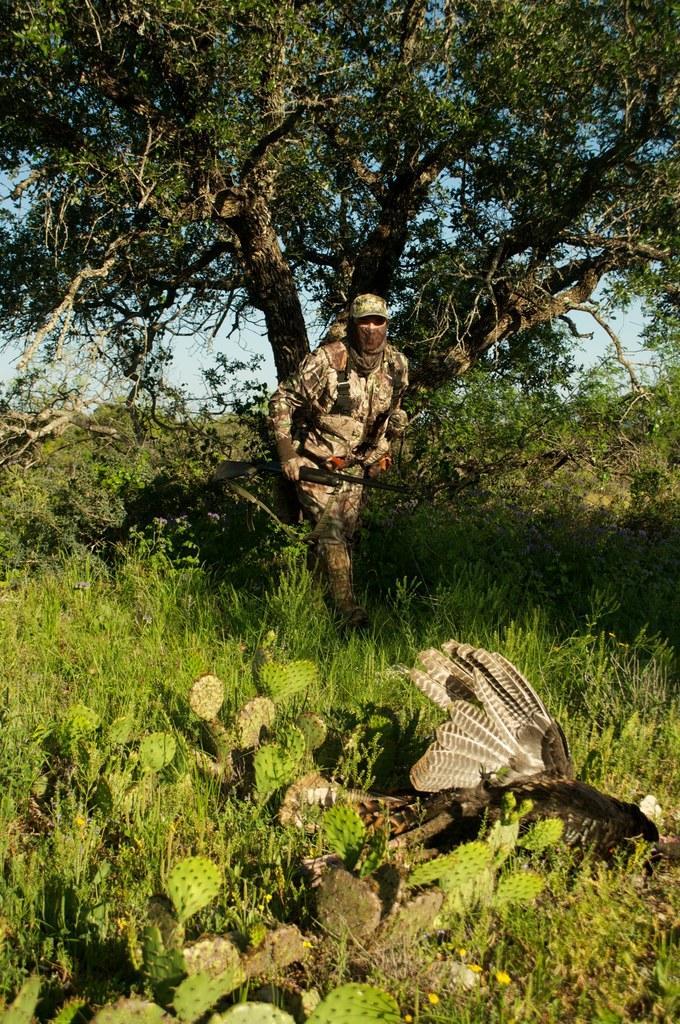Describe this image in one or two sentences. Here we can see a bird,grass and a cactus plant on the ground. There is a man walking on the ground by holding a gun in his hand. In the background there are trees and sky. 